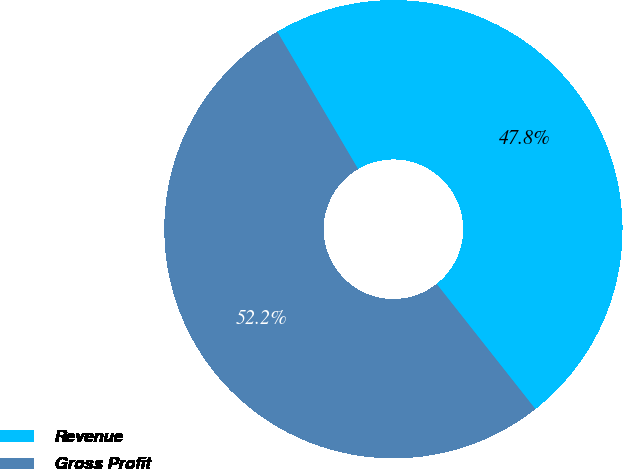Convert chart to OTSL. <chart><loc_0><loc_0><loc_500><loc_500><pie_chart><fcel>Revenue<fcel>Gross Profit<nl><fcel>47.83%<fcel>52.17%<nl></chart> 